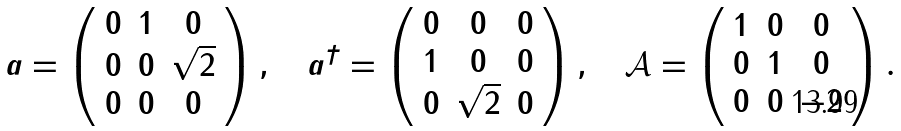Convert formula to latex. <formula><loc_0><loc_0><loc_500><loc_500>a = \left ( { \begin{array} { c c c c } { 0 } & { 1 } & { 0 } \\ { 0 } & { 0 } & { \sqrt { 2 } } \\ { 0 } & { 0 } & { 0 } \\ \end{array} } \right ) , \quad a ^ { \dagger } = \left ( { \begin{array} { c c c c } { 0 } & { 0 } & { 0 } \\ { 1 } & { 0 } & { 0 } \\ { 0 } & { \sqrt { 2 } } & { 0 } \\ \end{array} } \right ) , \quad \mathcal { A } = \left ( { \begin{array} { c c c c } { 1 } & { 0 } & { 0 } \\ { 0 } & { 1 } & { 0 } \\ { 0 } & { 0 } & { - 2 } \\ \end{array} } \right ) .</formula> 